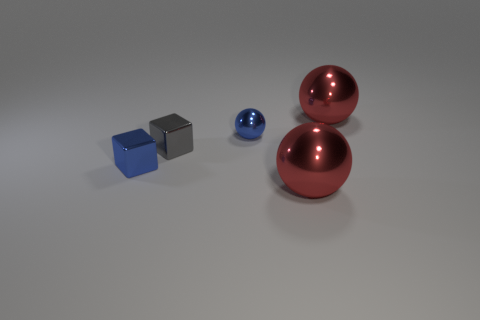There is a blue thing that is the same shape as the small gray metal object; what is its material?
Ensure brevity in your answer.  Metal. What is the size of the blue block that is the same material as the gray object?
Your answer should be very brief. Small. There is a shiny thing that is to the left of the small ball and to the right of the tiny blue metal block; what is its shape?
Your response must be concise. Cube. There is a red shiny thing in front of the red sphere behind the gray metal thing; how big is it?
Keep it short and to the point. Large. How many other objects are the same color as the small ball?
Your answer should be compact. 1. What material is the small gray thing?
Keep it short and to the point. Metal. Are any large red balls visible?
Your answer should be very brief. Yes. Is the number of small blue shiny spheres that are on the left side of the gray cube the same as the number of large purple matte cubes?
Your answer should be very brief. Yes. What number of small things are either red metal things or gray blocks?
Your response must be concise. 1. What is the shape of the thing that is the same color as the small shiny sphere?
Make the answer very short. Cube. 